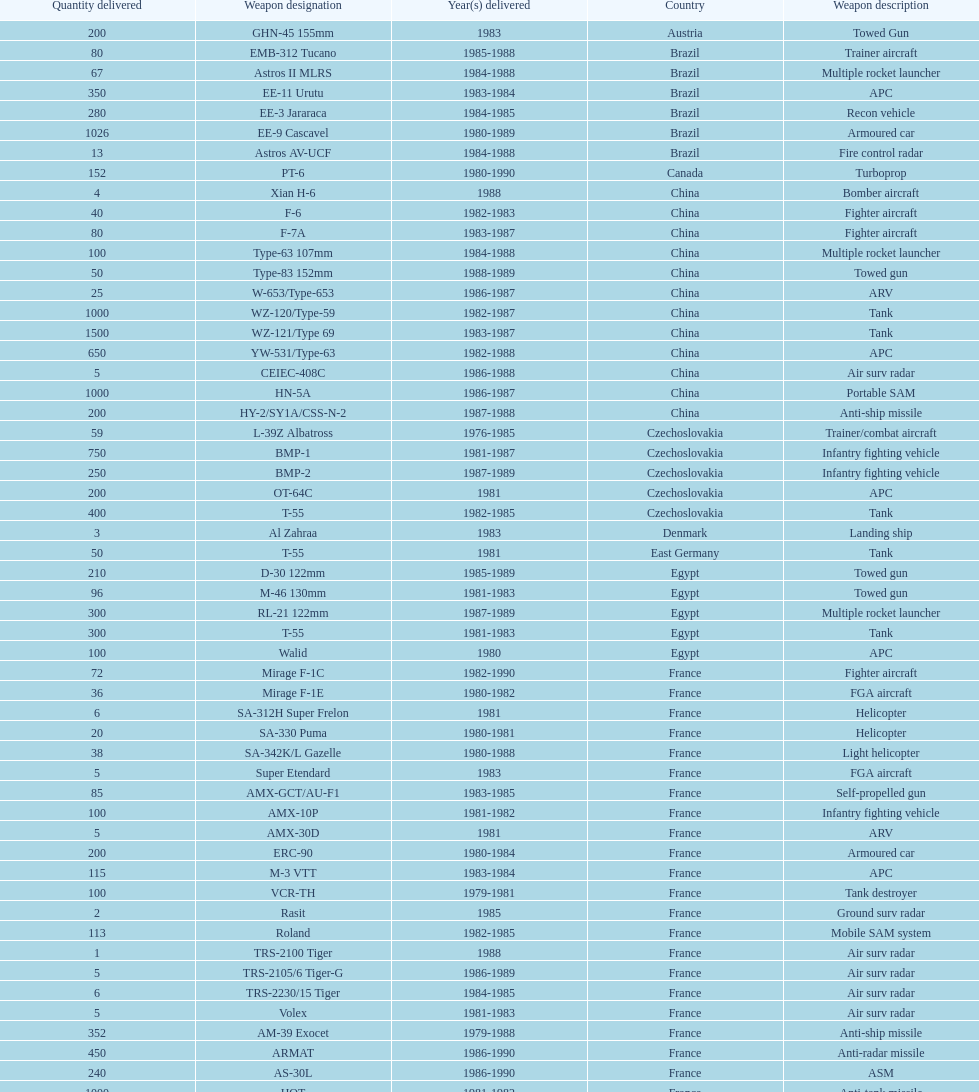Would you mind parsing the complete table? {'header': ['Quantity delivered', 'Weapon designation', 'Year(s) delivered', 'Country', 'Weapon description'], 'rows': [['200', 'GHN-45 155mm', '1983', 'Austria', 'Towed Gun'], ['80', 'EMB-312 Tucano', '1985-1988', 'Brazil', 'Trainer aircraft'], ['67', 'Astros II MLRS', '1984-1988', 'Brazil', 'Multiple rocket launcher'], ['350', 'EE-11 Urutu', '1983-1984', 'Brazil', 'APC'], ['280', 'EE-3 Jararaca', '1984-1985', 'Brazil', 'Recon vehicle'], ['1026', 'EE-9 Cascavel', '1980-1989', 'Brazil', 'Armoured car'], ['13', 'Astros AV-UCF', '1984-1988', 'Brazil', 'Fire control radar'], ['152', 'PT-6', '1980-1990', 'Canada', 'Turboprop'], ['4', 'Xian H-6', '1988', 'China', 'Bomber aircraft'], ['40', 'F-6', '1982-1983', 'China', 'Fighter aircraft'], ['80', 'F-7A', '1983-1987', 'China', 'Fighter aircraft'], ['100', 'Type-63 107mm', '1984-1988', 'China', 'Multiple rocket launcher'], ['50', 'Type-83 152mm', '1988-1989', 'China', 'Towed gun'], ['25', 'W-653/Type-653', '1986-1987', 'China', 'ARV'], ['1000', 'WZ-120/Type-59', '1982-1987', 'China', 'Tank'], ['1500', 'WZ-121/Type 69', '1983-1987', 'China', 'Tank'], ['650', 'YW-531/Type-63', '1982-1988', 'China', 'APC'], ['5', 'CEIEC-408C', '1986-1988', 'China', 'Air surv radar'], ['1000', 'HN-5A', '1986-1987', 'China', 'Portable SAM'], ['200', 'HY-2/SY1A/CSS-N-2', '1987-1988', 'China', 'Anti-ship missile'], ['59', 'L-39Z Albatross', '1976-1985', 'Czechoslovakia', 'Trainer/combat aircraft'], ['750', 'BMP-1', '1981-1987', 'Czechoslovakia', 'Infantry fighting vehicle'], ['250', 'BMP-2', '1987-1989', 'Czechoslovakia', 'Infantry fighting vehicle'], ['200', 'OT-64C', '1981', 'Czechoslovakia', 'APC'], ['400', 'T-55', '1982-1985', 'Czechoslovakia', 'Tank'], ['3', 'Al Zahraa', '1983', 'Denmark', 'Landing ship'], ['50', 'T-55', '1981', 'East Germany', 'Tank'], ['210', 'D-30 122mm', '1985-1989', 'Egypt', 'Towed gun'], ['96', 'M-46 130mm', '1981-1983', 'Egypt', 'Towed gun'], ['300', 'RL-21 122mm', '1987-1989', 'Egypt', 'Multiple rocket launcher'], ['300', 'T-55', '1981-1983', 'Egypt', 'Tank'], ['100', 'Walid', '1980', 'Egypt', 'APC'], ['72', 'Mirage F-1C', '1982-1990', 'France', 'Fighter aircraft'], ['36', 'Mirage F-1E', '1980-1982', 'France', 'FGA aircraft'], ['6', 'SA-312H Super Frelon', '1981', 'France', 'Helicopter'], ['20', 'SA-330 Puma', '1980-1981', 'France', 'Helicopter'], ['38', 'SA-342K/L Gazelle', '1980-1988', 'France', 'Light helicopter'], ['5', 'Super Etendard', '1983', 'France', 'FGA aircraft'], ['85', 'AMX-GCT/AU-F1', '1983-1985', 'France', 'Self-propelled gun'], ['100', 'AMX-10P', '1981-1982', 'France', 'Infantry fighting vehicle'], ['5', 'AMX-30D', '1981', 'France', 'ARV'], ['200', 'ERC-90', '1980-1984', 'France', 'Armoured car'], ['115', 'M-3 VTT', '1983-1984', 'France', 'APC'], ['100', 'VCR-TH', '1979-1981', 'France', 'Tank destroyer'], ['2', 'Rasit', '1985', 'France', 'Ground surv radar'], ['113', 'Roland', '1982-1985', 'France', 'Mobile SAM system'], ['1', 'TRS-2100 Tiger', '1988', 'France', 'Air surv radar'], ['5', 'TRS-2105/6 Tiger-G', '1986-1989', 'France', 'Air surv radar'], ['6', 'TRS-2230/15 Tiger', '1984-1985', 'France', 'Air surv radar'], ['5', 'Volex', '1981-1983', 'France', 'Air surv radar'], ['352', 'AM-39 Exocet', '1979-1988', 'France', 'Anti-ship missile'], ['450', 'ARMAT', '1986-1990', 'France', 'Anti-radar missile'], ['240', 'AS-30L', '1986-1990', 'France', 'ASM'], ['1000', 'HOT', '1981-1982', 'France', 'Anti-tank missile'], ['534', 'R-550 Magic-1', '1981-1985', 'France', 'SRAAM'], ['2260', 'Roland-2', '1981-1990', 'France', 'SAM'], ['300', 'Super 530F', '1981-1985', 'France', 'BVRAAM'], ['22', 'BK-117', '1984-1989', 'West Germany', 'Helicopter'], ['20', 'Bo-105C', '1979-1982', 'West Germany', 'Light Helicopter'], ['6', 'Bo-105L', '1988', 'West Germany', 'Light Helicopter'], ['300', 'PSZH-D-994', '1981', 'Hungary', 'APC'], ['2', 'A-109 Hirundo', '1982', 'Italy', 'Light Helicopter'], ['6', 'S-61', '1982', 'Italy', 'Helicopter'], ['1', 'Stromboli class', '1981', 'Italy', 'Support ship'], ['2', 'S-76 Spirit', '1985', 'Jordan', 'Helicopter'], ['15', 'Mi-2/Hoplite', '1984-1985', 'Poland', 'Helicopter'], ['750', 'MT-LB', '1983-1990', 'Poland', 'APC'], ['400', 'T-55', '1981-1982', 'Poland', 'Tank'], ['500', 'T-72M1', '1982-1990', 'Poland', 'Tank'], ['150', 'T-55', '1982-1984', 'Romania', 'Tank'], ['2', 'M-87 Orkan 262mm', '1988', 'Yugoslavia', 'Multiple rocket launcher'], ['200', 'G-5 155mm', '1985-1988', 'South Africa', 'Towed gun'], ['52', 'PC-7 Turbo trainer', '1980-1983', 'Switzerland', 'Trainer aircraft'], ['20', 'PC-9', '1987-1990', 'Switzerland', 'Trainer aircraft'], ['100', 'Roland', '1981', 'Switzerland', 'APC/IFV'], ['29', 'Chieftain/ARV', '1982', 'United Kingdom', 'ARV'], ['10', 'Cymbeline', '1986-1988', 'United Kingdom', 'Arty locating radar'], ['30', 'MD-500MD Defender', '1983', 'United States', 'Light Helicopter'], ['30', 'Hughes-300/TH-55', '1983', 'United States', 'Light Helicopter'], ['26', 'MD-530F', '1986', 'United States', 'Light Helicopter'], ['31', 'Bell 214ST', '1988', 'United States', 'Helicopter'], ['33', 'Il-76M/Candid-B', '1978-1984', 'Soviet Union', 'Strategic airlifter'], ['12', 'Mi-24D/Mi-25/Hind-D', '1978-1984', 'Soviet Union', 'Attack helicopter'], ['37', 'Mi-8/Mi-17/Hip-H', '1986-1987', 'Soviet Union', 'Transport helicopter'], ['30', 'Mi-8TV/Hip-F', '1984', 'Soviet Union', 'Transport helicopter'], ['61', 'Mig-21bis/Fishbed-N', '1983-1984', 'Soviet Union', 'Fighter aircraft'], ['50', 'Mig-23BN/Flogger-H', '1984-1985', 'Soviet Union', 'FGA aircraft'], ['55', 'Mig-25P/Foxbat-A', '1980-1985', 'Soviet Union', 'Interceptor aircraft'], ['8', 'Mig-25RB/Foxbat-B', '1982', 'Soviet Union', 'Recon aircraft'], ['41', 'Mig-29/Fulcrum-A', '1986-1989', 'Soviet Union', 'Fighter aircraft'], ['61', 'Su-22/Fitter-H/J/K', '1986-1987', 'Soviet Union', 'FGA aircraft'], ['84', 'Su-25/Frogfoot-A', '1986-1987', 'Soviet Union', 'Ground attack aircraft'], ['180', '2A36 152mm', '1986-1988', 'Soviet Union', 'Towed gun'], ['150', '2S1 122mm', '1980-1989', 'Soviet Union', 'Self-Propelled Howitzer'], ['150', '2S3 152mm', '1980-1989', 'Soviet Union', 'Self-propelled gun'], ['10', '2S4 240mm', '1983', 'Soviet Union', 'Self-propelled mortar'], ['10', '9P117/SS-1 Scud TEL', '1983-1984', 'Soviet Union', 'SSM launcher'], ['560', 'BM-21 Grad 122mm', '1983-1988', 'Soviet Union', 'Multiple rocket launcher'], ['576', 'D-30 122mm', '1982-1988', 'Soviet Union', 'Towed gun'], ['25', 'M-240 240mm', '1981', 'Soviet Union', 'Mortar'], ['576', 'M-46 130mm', '1982-1987', 'Soviet Union', 'Towed Gun'], ['30', '9K35 Strela-10/SA-13', '1985', 'Soviet Union', 'AAV(M)'], ['10', 'BMD-1', '1981', 'Soviet Union', 'IFV'], ['200', 'PT-76', '1984', 'Soviet Union', 'Light tank'], ['160', 'SA-9/9P31', '1982-1985', 'Soviet Union', 'AAV(M)'], ['10', 'Long Track', '1980-1984', 'Soviet Union', 'Air surv radar'], ['50', 'SA-8b/9K33M Osa AK', '1982-1985', 'Soviet Union', 'Mobile SAM system'], ['5', 'Thin Skin', '1980-1984', 'Soviet Union', 'Air surv radar'], ['3000', '9M111/AT-4 Spigot', '1986-1989', 'Soviet Union', 'Anti-tank missile'], ['960', '9M37/SA-13 Gopher', '1985-1986', 'Soviet Union', 'SAM'], ['36', 'KSR-5/AS-6 Kingfish', '1984', 'Soviet Union', 'Anti-ship missile'], ['250', 'Kh-28/AS-9 Kyle', '1983-1988', 'Soviet Union', 'Anti-radar missile'], ['1080', 'R-13S/AA2S Atoll', '1984-1987', 'Soviet Union', 'SRAAM'], ['840', 'R-17/SS-1c Scud-B', '1982-1988', 'Soviet Union', 'SSM'], ['246', 'R-27/AA-10 Alamo', '1986-1989', 'Soviet Union', 'BVRAAM'], ['660', 'R-40R/AA-6 Acrid', '1980-1985', 'Soviet Union', 'BVRAAM'], ['582', 'R-60/AA-8 Aphid', '1986-1989', 'Soviet Union', 'SRAAM'], ['1290', 'SA-8b Gecko/9M33M', '1982-1985', 'Soviet Union', 'SAM'], ['1920', 'SA-9 Gaskin/9M31', '1982-1985', 'Soviet Union', 'SAM'], ['500', 'Strela-3/SA-14 Gremlin', '1987-1988', 'Soviet Union', 'Portable SAM']]} Which was the first country to sell weapons to iraq? Czechoslovakia. 